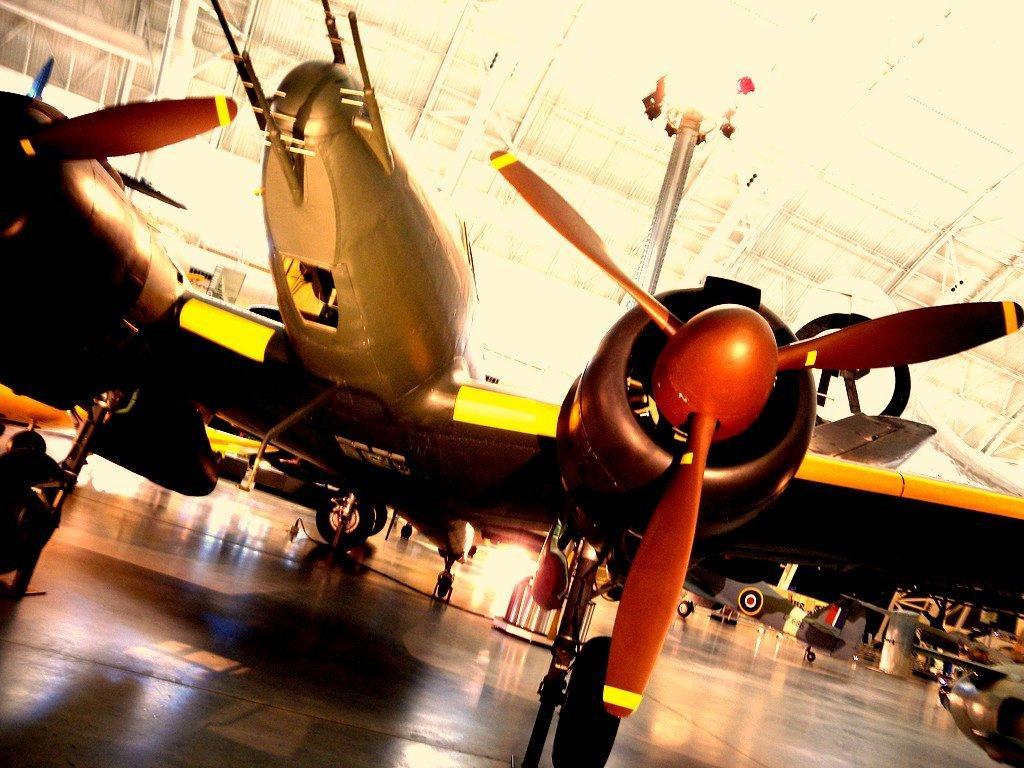Describe this image in one or two sentences. In this image I can see airplanes and other objects. Here I can see lights. 